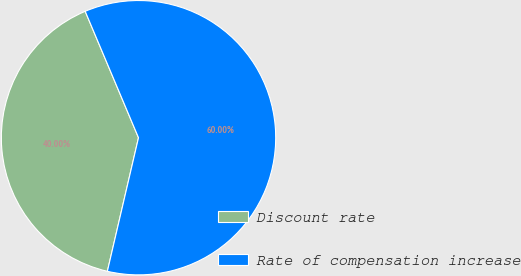Convert chart to OTSL. <chart><loc_0><loc_0><loc_500><loc_500><pie_chart><fcel>Discount rate<fcel>Rate of compensation increase<nl><fcel>40.0%<fcel>60.0%<nl></chart> 